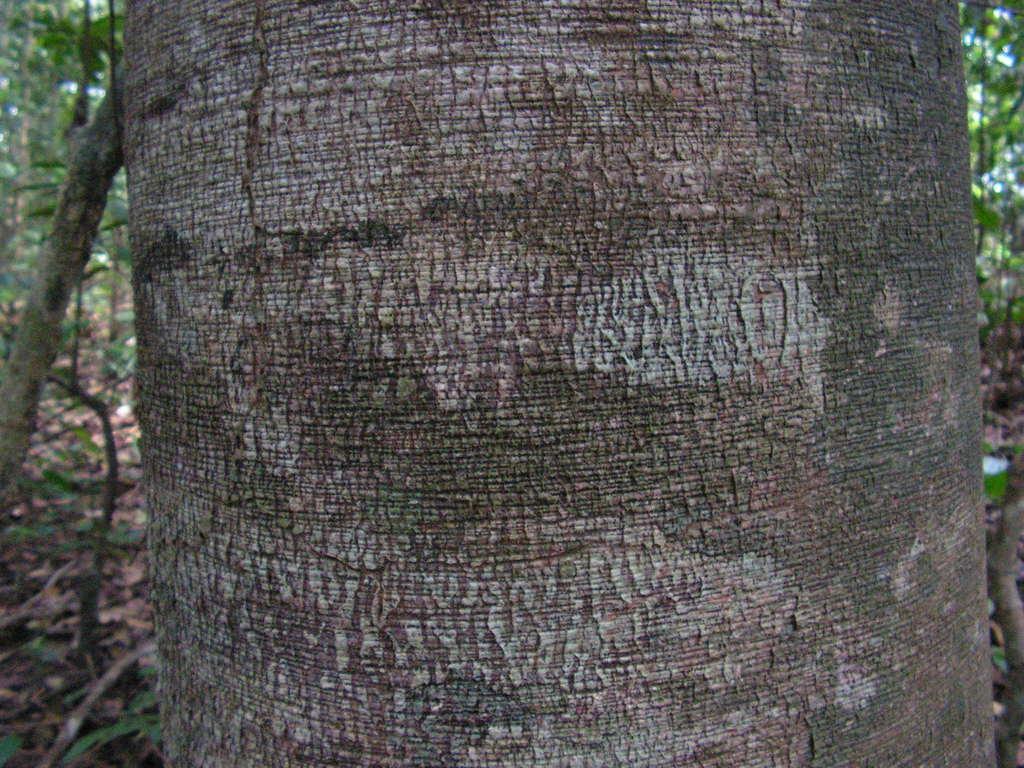In one or two sentences, can you explain what this image depicts? In the foreground, I can see a trunk. In the background there are many trees and plants on the ground. 